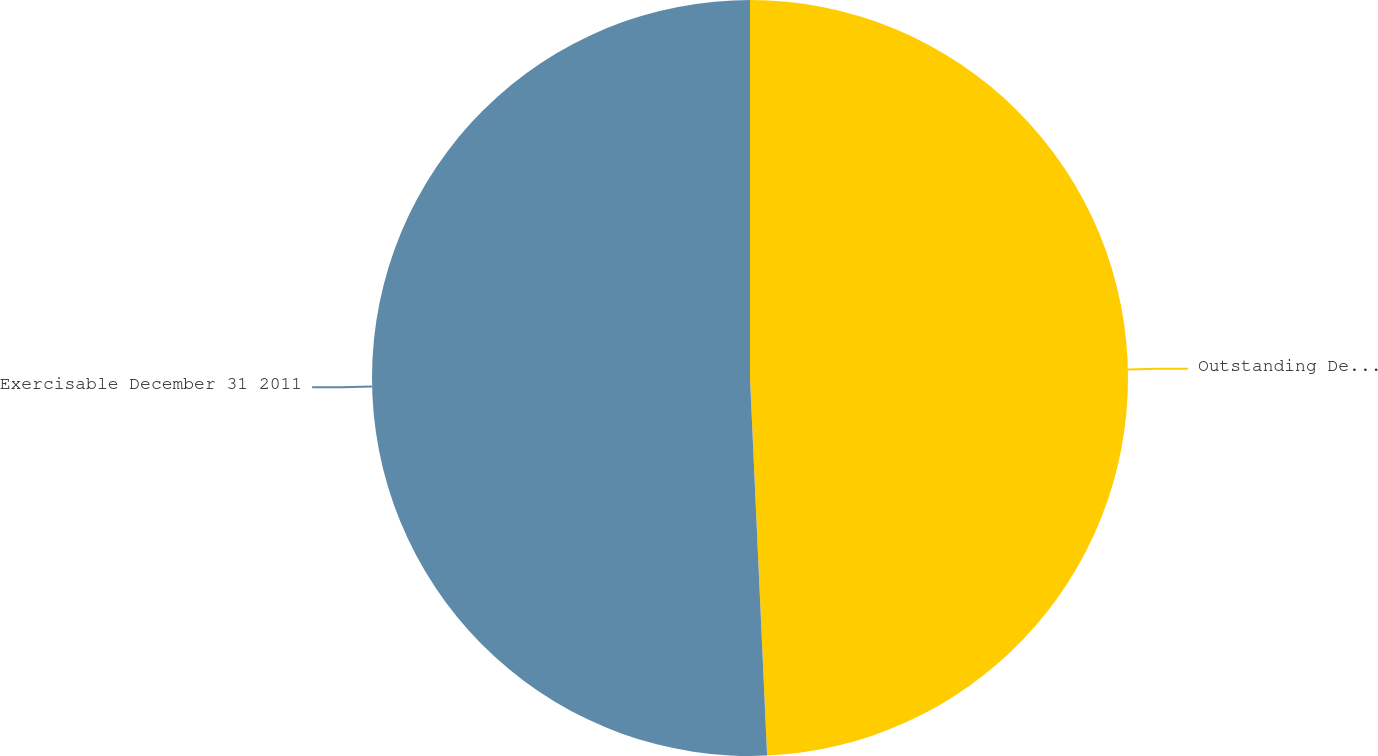Convert chart. <chart><loc_0><loc_0><loc_500><loc_500><pie_chart><fcel>Outstanding December 31 2011<fcel>Exercisable December 31 2011<nl><fcel>49.28%<fcel>50.72%<nl></chart> 